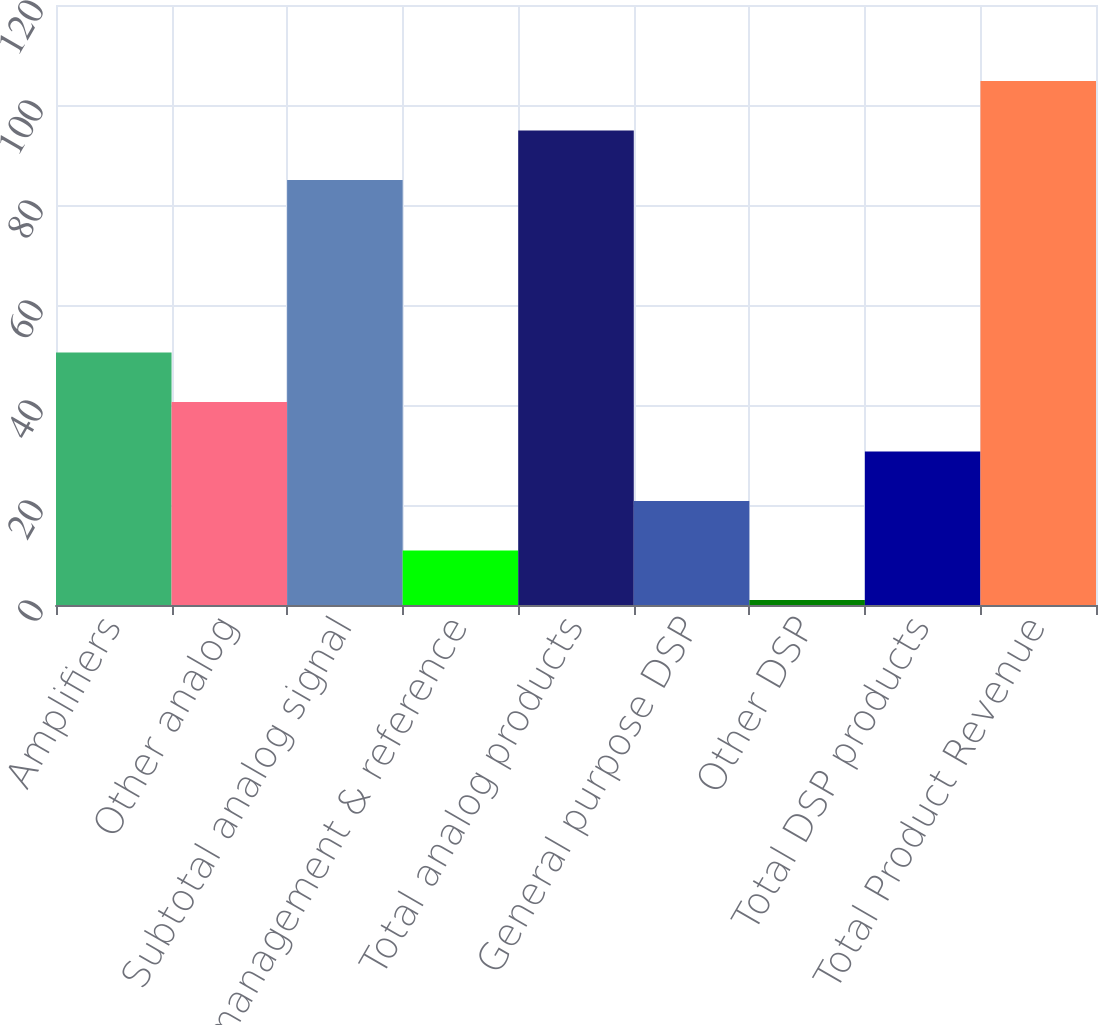Convert chart. <chart><loc_0><loc_0><loc_500><loc_500><bar_chart><fcel>Amplifiers<fcel>Other analog<fcel>Subtotal analog signal<fcel>Power management & reference<fcel>Total analog products<fcel>General purpose DSP<fcel>Other DSP<fcel>Total DSP products<fcel>Total Product Revenue<nl><fcel>50.5<fcel>40.6<fcel>85<fcel>10.9<fcel>94.9<fcel>20.8<fcel>1<fcel>30.7<fcel>104.8<nl></chart> 